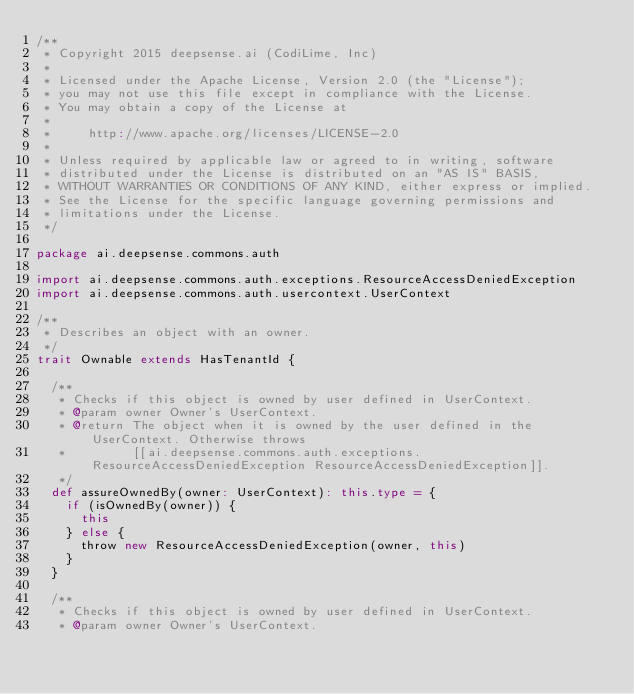<code> <loc_0><loc_0><loc_500><loc_500><_Scala_>/**
 * Copyright 2015 deepsense.ai (CodiLime, Inc)
 *
 * Licensed under the Apache License, Version 2.0 (the "License");
 * you may not use this file except in compliance with the License.
 * You may obtain a copy of the License at
 *
 *     http://www.apache.org/licenses/LICENSE-2.0
 *
 * Unless required by applicable law or agreed to in writing, software
 * distributed under the License is distributed on an "AS IS" BASIS,
 * WITHOUT WARRANTIES OR CONDITIONS OF ANY KIND, either express or implied.
 * See the License for the specific language governing permissions and
 * limitations under the License.
 */

package ai.deepsense.commons.auth

import ai.deepsense.commons.auth.exceptions.ResourceAccessDeniedException
import ai.deepsense.commons.auth.usercontext.UserContext

/**
 * Describes an object with an owner.
 */
trait Ownable extends HasTenantId {

  /**
   * Checks if this object is owned by user defined in UserContext.
   * @param owner Owner's UserContext.
   * @return The object when it is owned by the user defined in the UserContext. Otherwise throws
   *         [[ai.deepsense.commons.auth.exceptions.ResourceAccessDeniedException ResourceAccessDeniedException]].
   */
  def assureOwnedBy(owner: UserContext): this.type = {
    if (isOwnedBy(owner)) {
      this
    } else {
      throw new ResourceAccessDeniedException(owner, this)
    }
  }

  /**
   * Checks if this object is owned by user defined in UserContext.
   * @param owner Owner's UserContext.</code> 